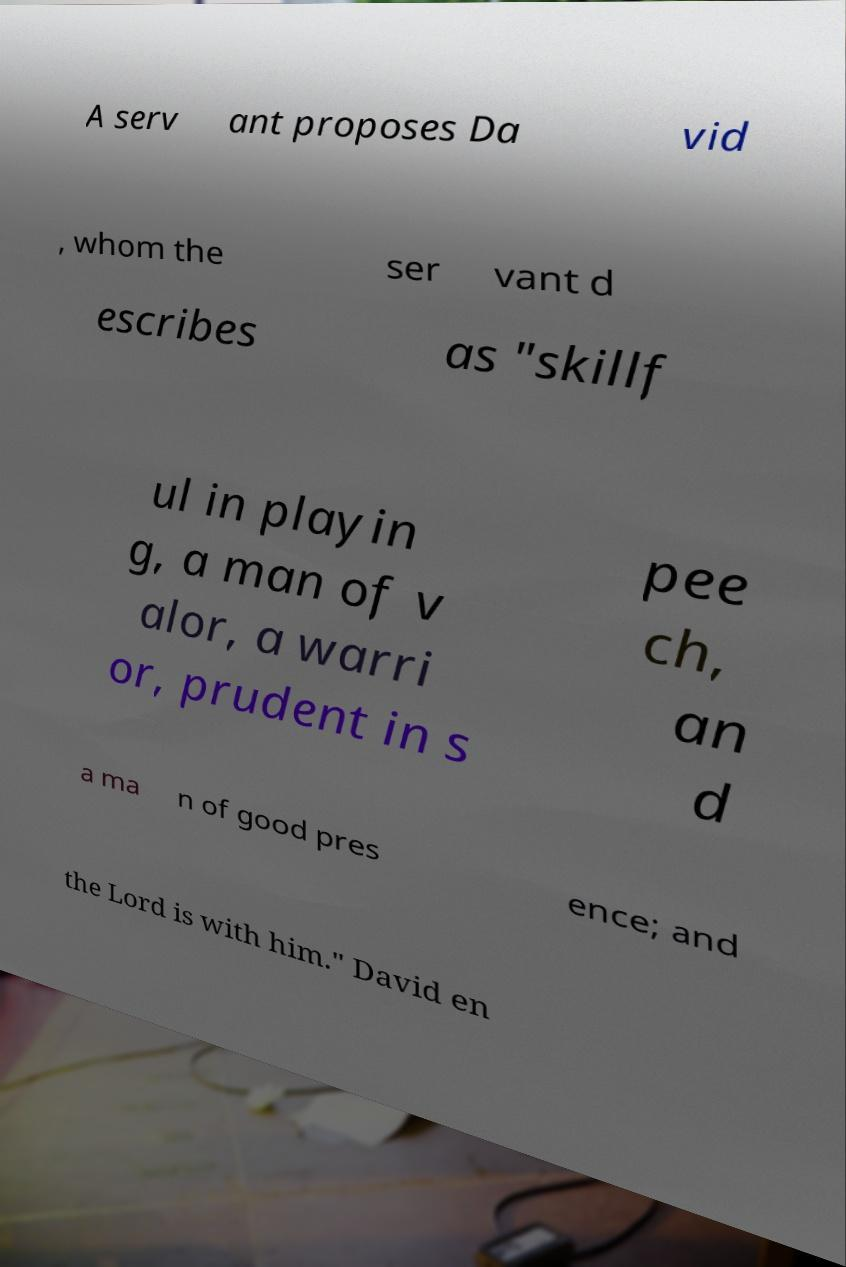What messages or text are displayed in this image? I need them in a readable, typed format. A serv ant proposes Da vid , whom the ser vant d escribes as "skillf ul in playin g, a man of v alor, a warri or, prudent in s pee ch, an d a ma n of good pres ence; and the Lord is with him." David en 